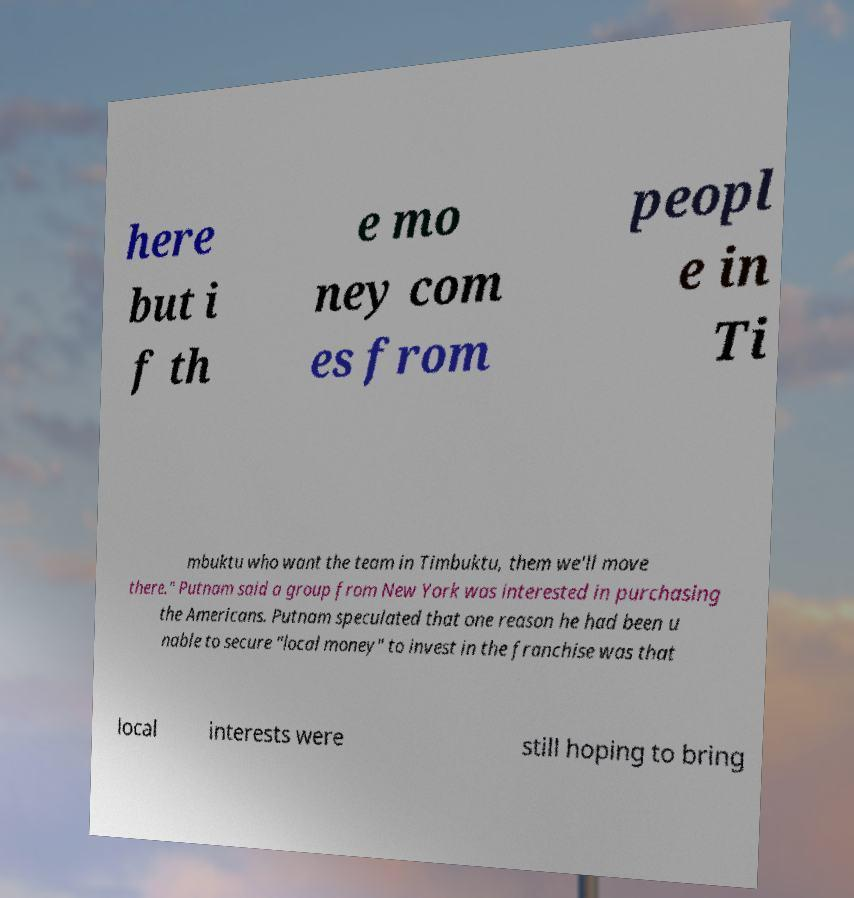Could you extract and type out the text from this image? here but i f th e mo ney com es from peopl e in Ti mbuktu who want the team in Timbuktu, them we'll move there." Putnam said a group from New York was interested in purchasing the Americans. Putnam speculated that one reason he had been u nable to secure "local money" to invest in the franchise was that local interests were still hoping to bring 